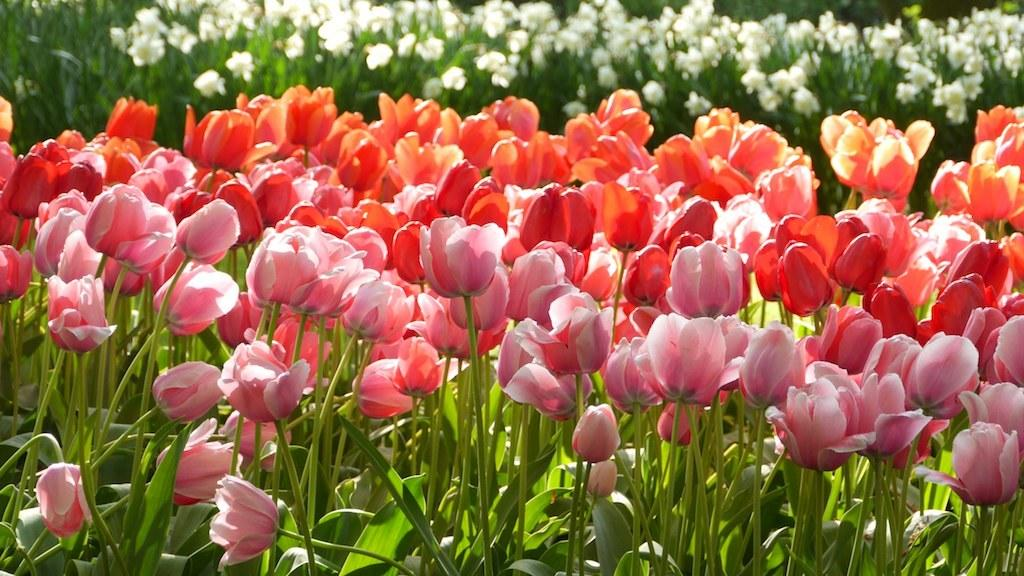What type of living organisms can be seen in the image? Flower plants can be seen in the image. What type of pie is being served on a plate in the image? There is no pie present in the image; it only features flower plants. 